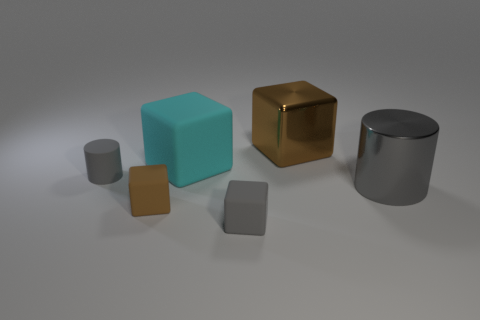What is the color of the thing that is the same material as the big brown block?
Keep it short and to the point. Gray. There is a cube that is behind the big cylinder and in front of the big shiny cube; what size is it?
Keep it short and to the point. Large. Are there fewer small matte cylinders behind the large cyan rubber object than shiny cylinders that are right of the small brown thing?
Offer a terse response. Yes. Does the large block that is in front of the large brown metal object have the same material as the tiny cube to the right of the big matte block?
Your response must be concise. Yes. There is a block that is the same color as the large cylinder; what is its material?
Offer a very short reply. Rubber. There is a object that is both on the right side of the cyan object and in front of the gray metal cylinder; what shape is it?
Keep it short and to the point. Cube. The brown thing behind the tiny matte cube behind the gray rubber block is made of what material?
Offer a very short reply. Metal. Is the number of gray matte things greater than the number of large yellow rubber cylinders?
Your answer should be very brief. Yes. Do the tiny cylinder and the large metal cylinder have the same color?
Provide a short and direct response. Yes. What material is the gray cylinder that is the same size as the cyan block?
Offer a very short reply. Metal. 